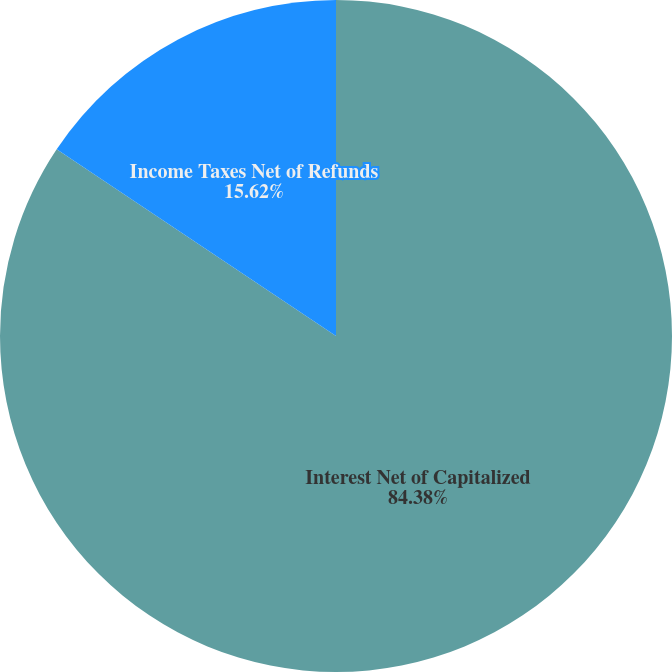<chart> <loc_0><loc_0><loc_500><loc_500><pie_chart><fcel>Interest Net of Capitalized<fcel>Income Taxes Net of Refunds<nl><fcel>84.38%<fcel>15.62%<nl></chart> 